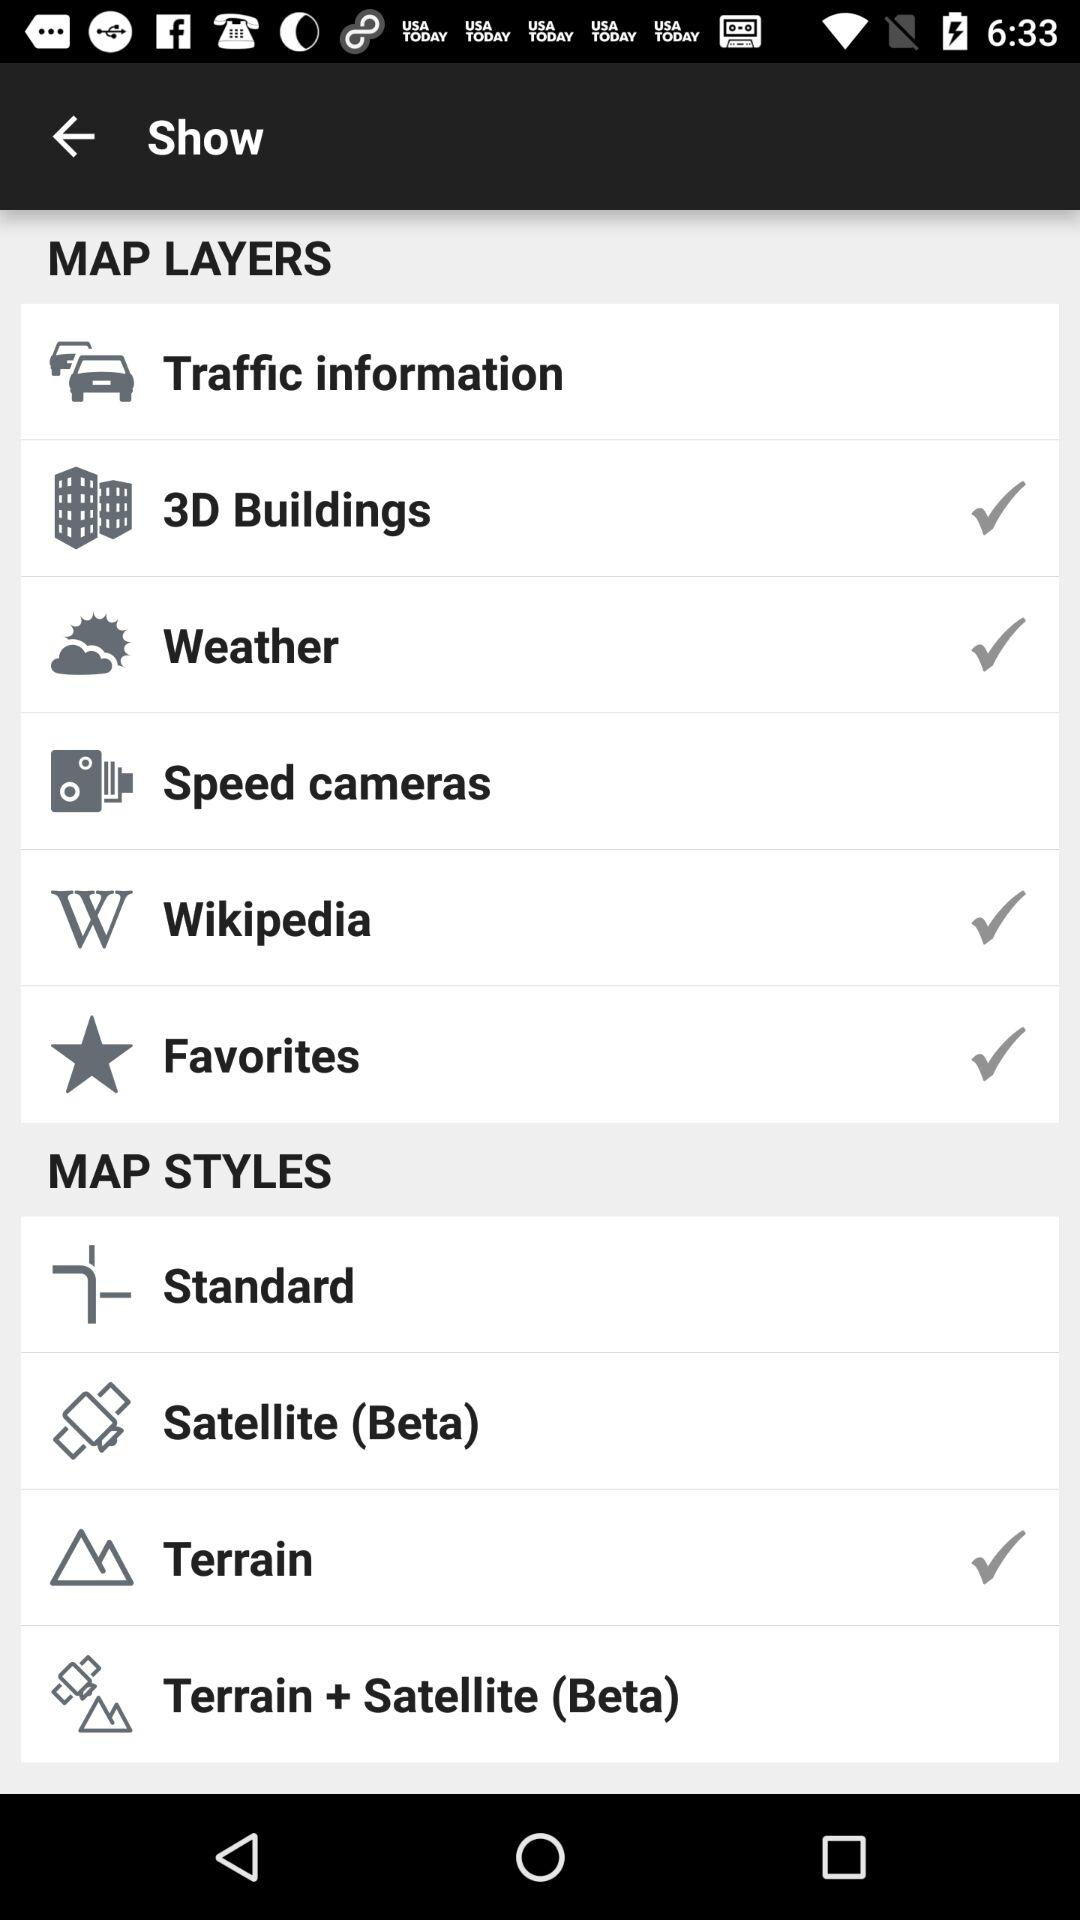How many map styles are available?
Answer the question using a single word or phrase. 4 